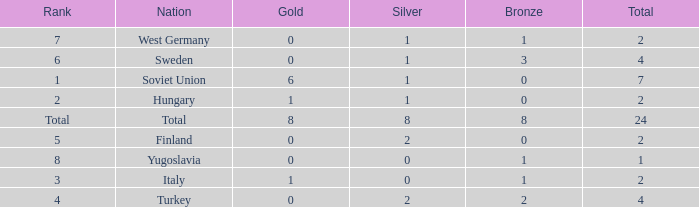What is the highest Total, when Gold is 1, when Nation is Hungary, and when Bronze is less than 0? None. 